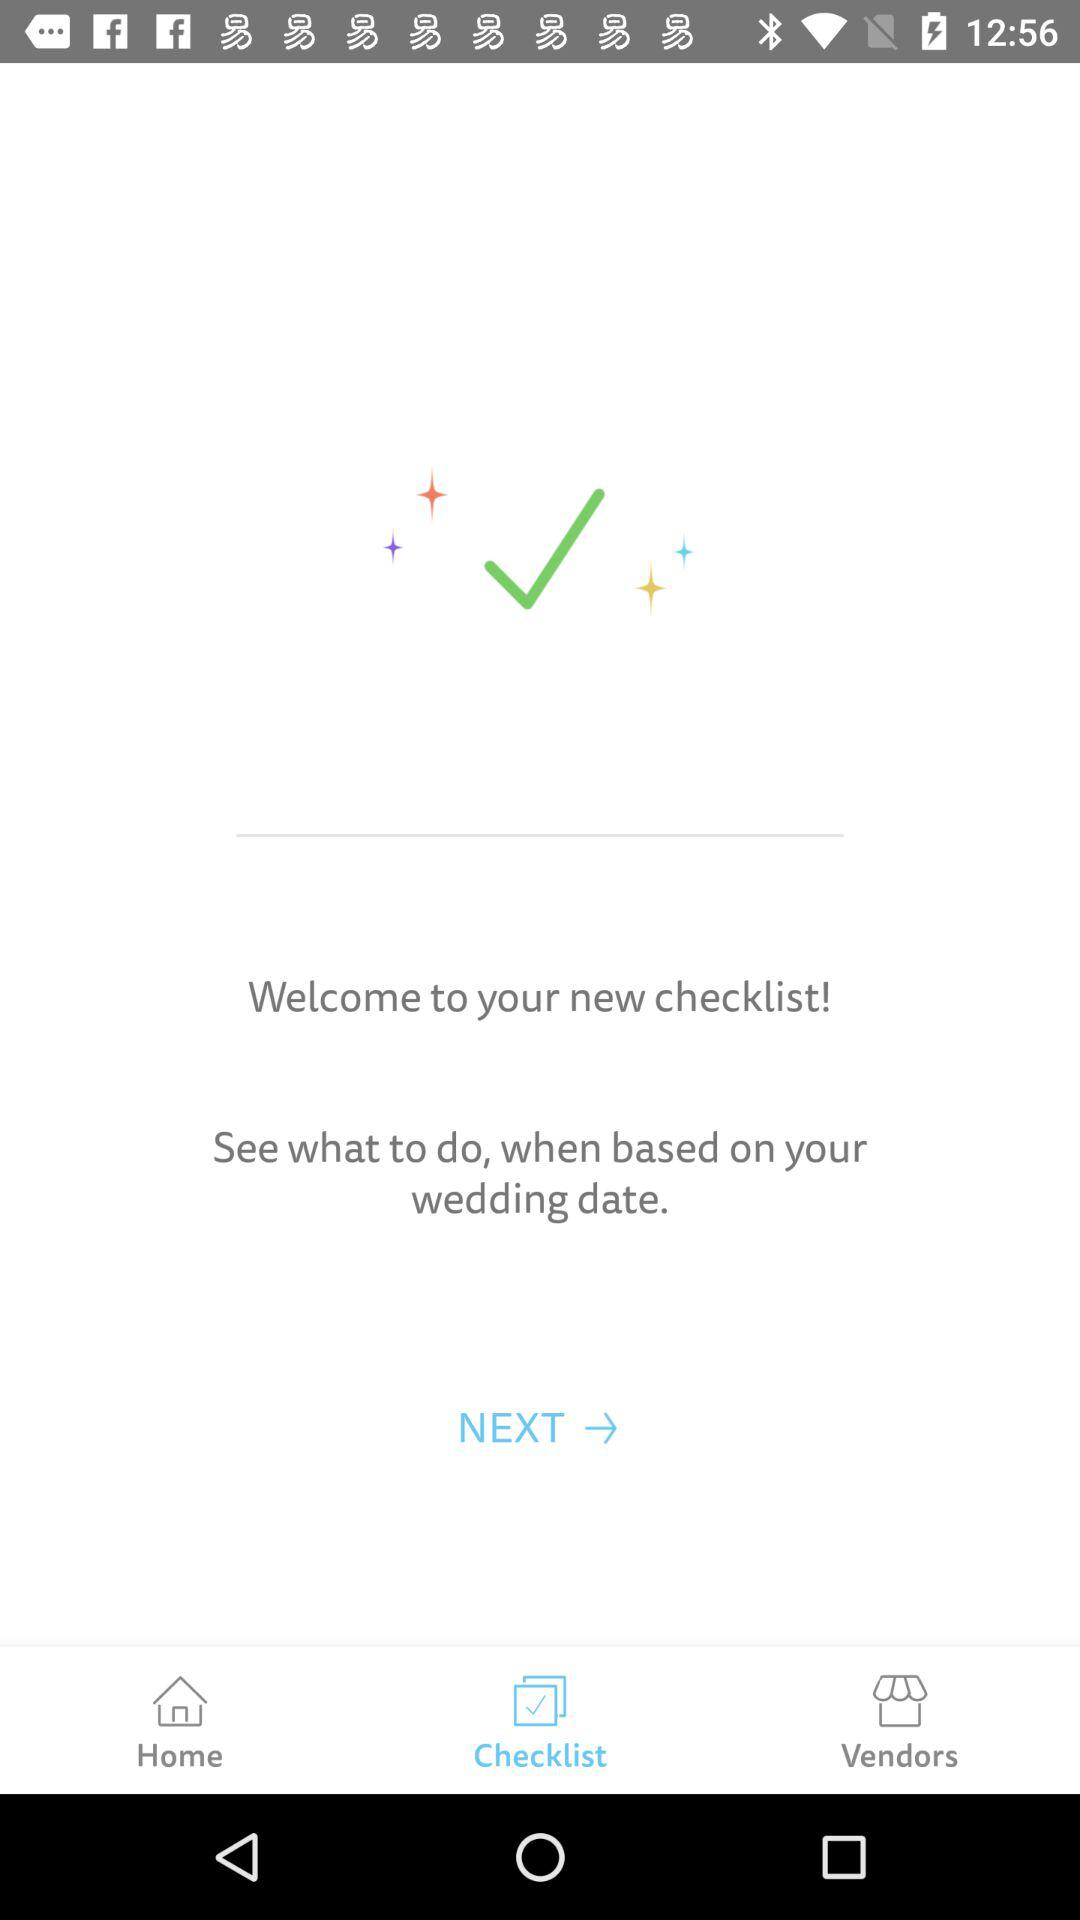Which date is selected for the wedding?
When the provided information is insufficient, respond with <no answer>. <no answer> 